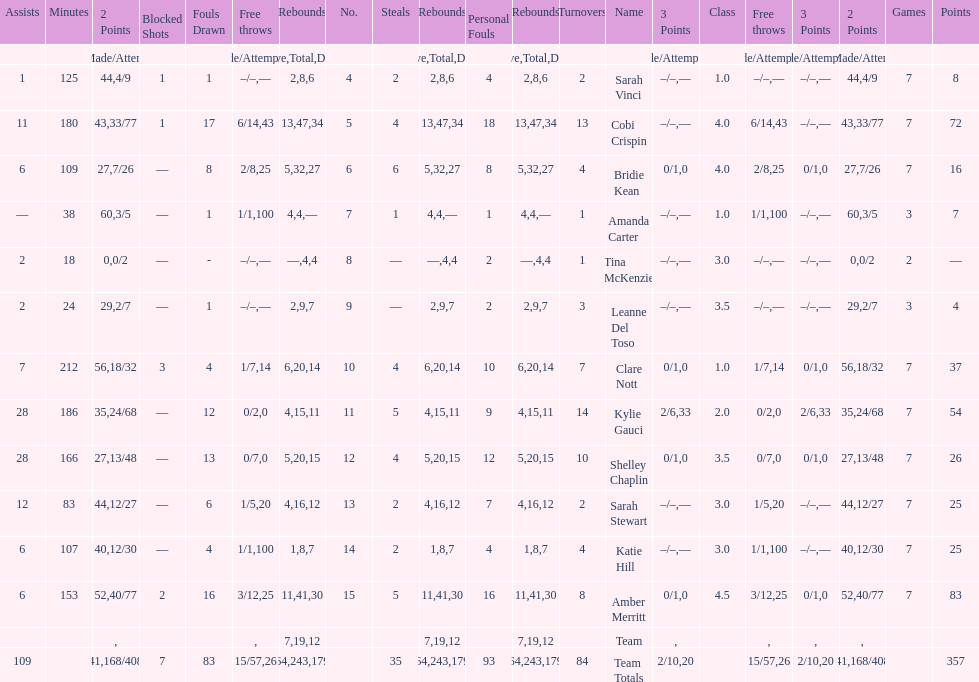Total number of assists and turnovers combined 193. 